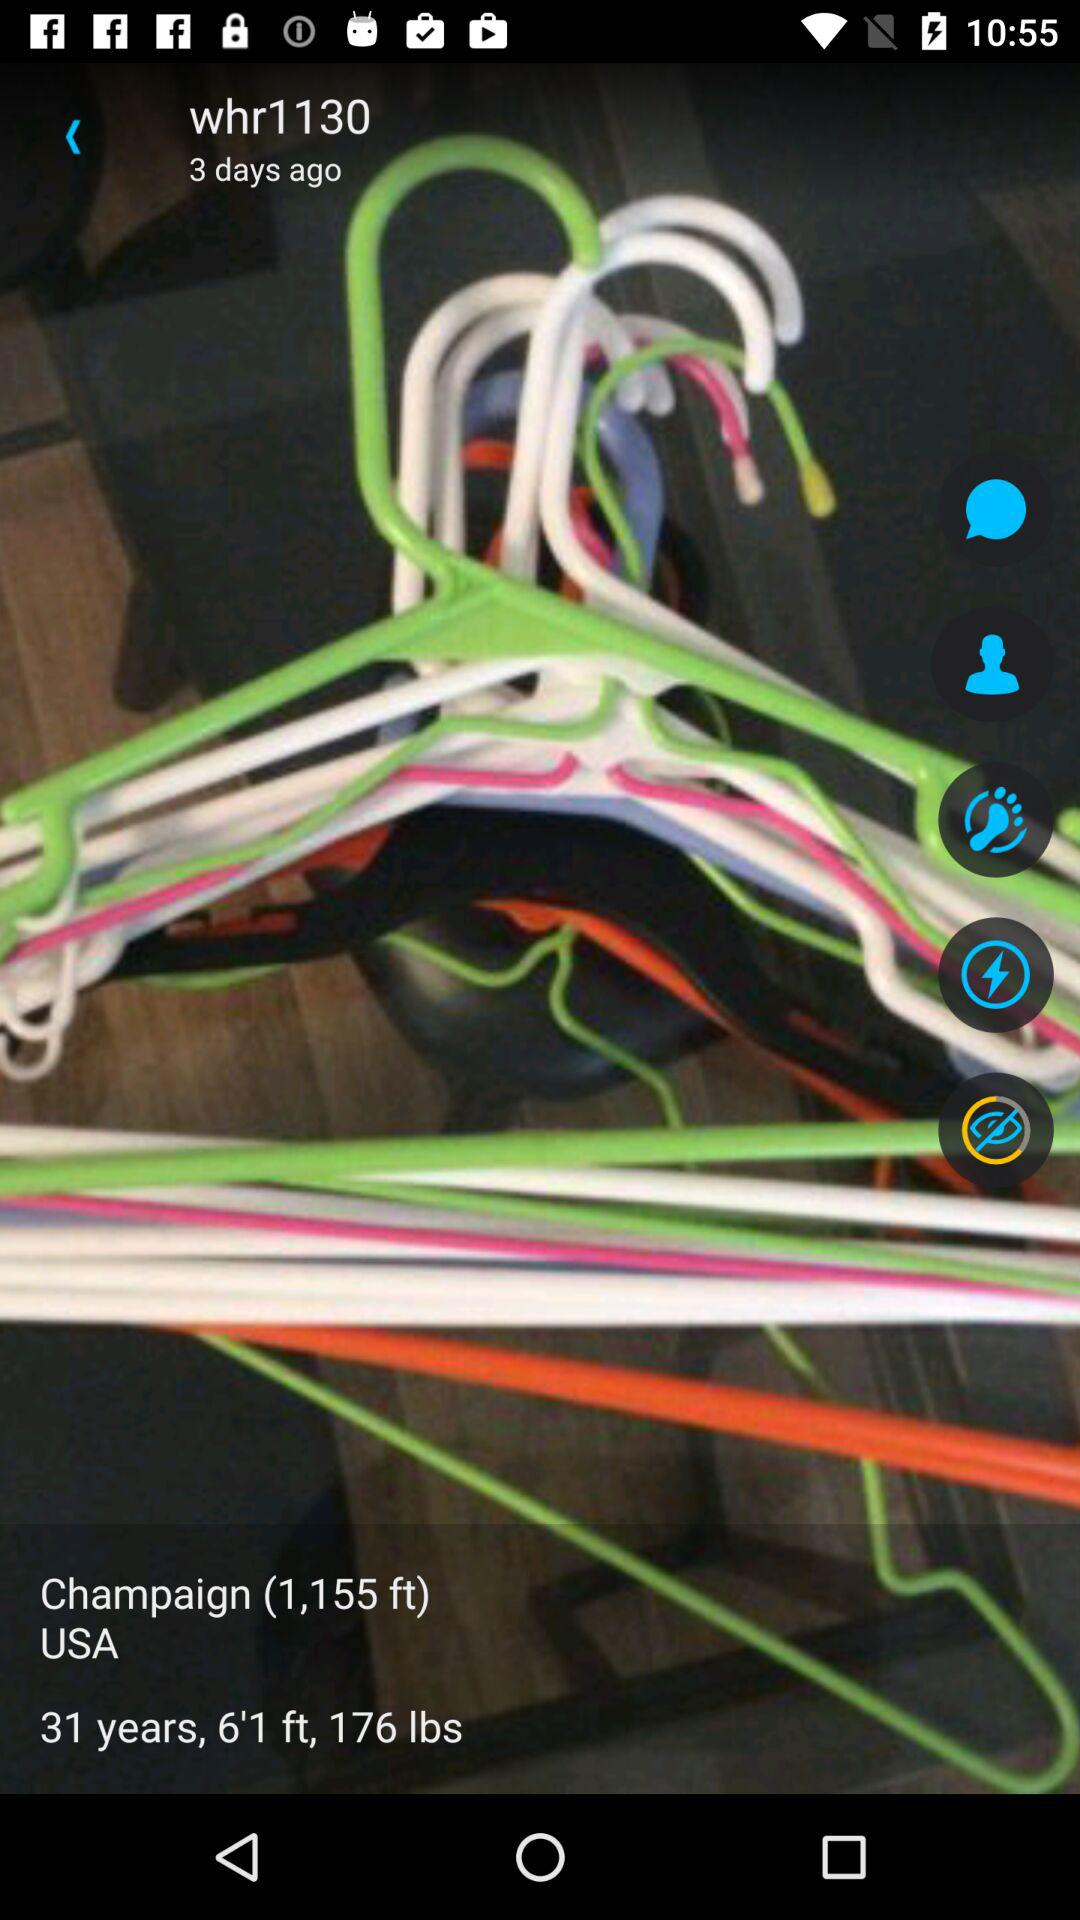What is the displayed age in years? The displayed age is 31 years. 